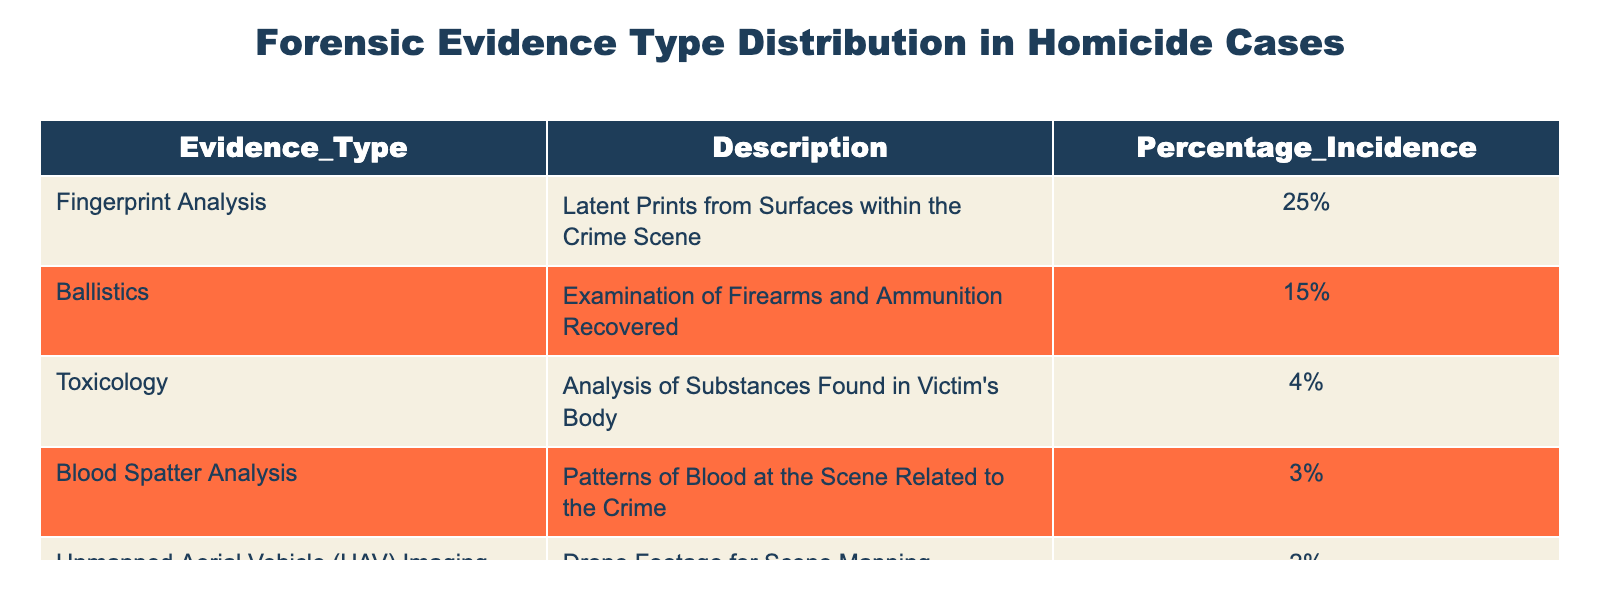What is the percentage incidence of Fingerprint Analysis in homicide cases? The table directly lists the percentage for Fingerprint Analysis as 25%. This information can be found in the 'Percentage_Incidence' column corresponding to 'Fingerprint Analysis'.
Answer: 25% What type of evidence has the lowest percentage incidence? By inspecting the table, Toxicology shows the lowest incidence at 4%. This is determined by comparing all percentages listed in the table.
Answer: Toxicology How much higher is the percentage incidence of Ballistics compared to Blood Spatter Analysis? The incidence for Ballistics is 15% and for Blood Spatter Analysis is 3%. The difference is calculated by subtracting 3 from 15, which equals 12%.
Answer: 12% Is the percentage incidence of Unmanned Aerial Vehicle Imaging greater than 3%? The table shows that the incidence for Unmanned Aerial Vehicle Imaging is 2%, which is less than 3%. Thus, the answer is no.
Answer: No What is the total percentage incidence of all the evidence types listed in the table? Adding all the percentages together: 25% + 15% + 4% + 3% + 2% = 49%. Therefore, the total percentage incidence is less than 100%, indicating other evidence types may exist.
Answer: 49% How does the combined percentage of Blood Spatter Analysis and Toxicology compare to the percentage of Fingerprint Analysis? Blood Spatter Analysis is 3% and Toxicology is 4%, totaling 7%. This is compared to Fingerprint Analysis at 25%. Since 7% is much less than 25%, we can conclude that the combined percentage is significantly lower.
Answer: Combined percentage is lower Which evidence type has a greater incidence: Blood Spatter Analysis or the combination of Toxicology and Unmanned Aerial Vehicle Imaging? Blood Spatter Analysis is 3%, while Toxicology (4%) and Unmanned Aerial Vehicle Imaging (2%) combined total 6%. Therefore, since 6% is higher than 3%, it indicates that the combination is greater.
Answer: Combination is greater What can be inferred about the focus of forensic investigations in homicide cases based on the evidence type distributions? The larger percentage of Fingerprint Analysis (25%) emphasizes its importance in forensic investigations, while lesser percentages like Toxicology (4%) and UAV Imaging (2%) suggest these areas are less frequently utilized, possibly indicating priority or resource allocation in investigations.
Answer: Focus on Fingerprints 